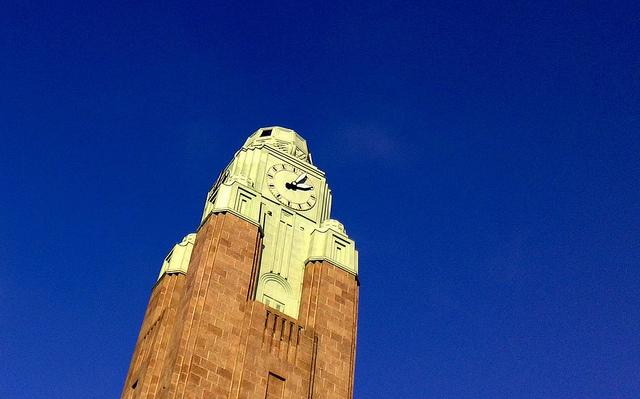Was the person who took this picture pointing the camera up?
Be succinct. Yes. How many clock hands are there?
Give a very brief answer. 2. What time is it?
Answer briefly. 2:05. 